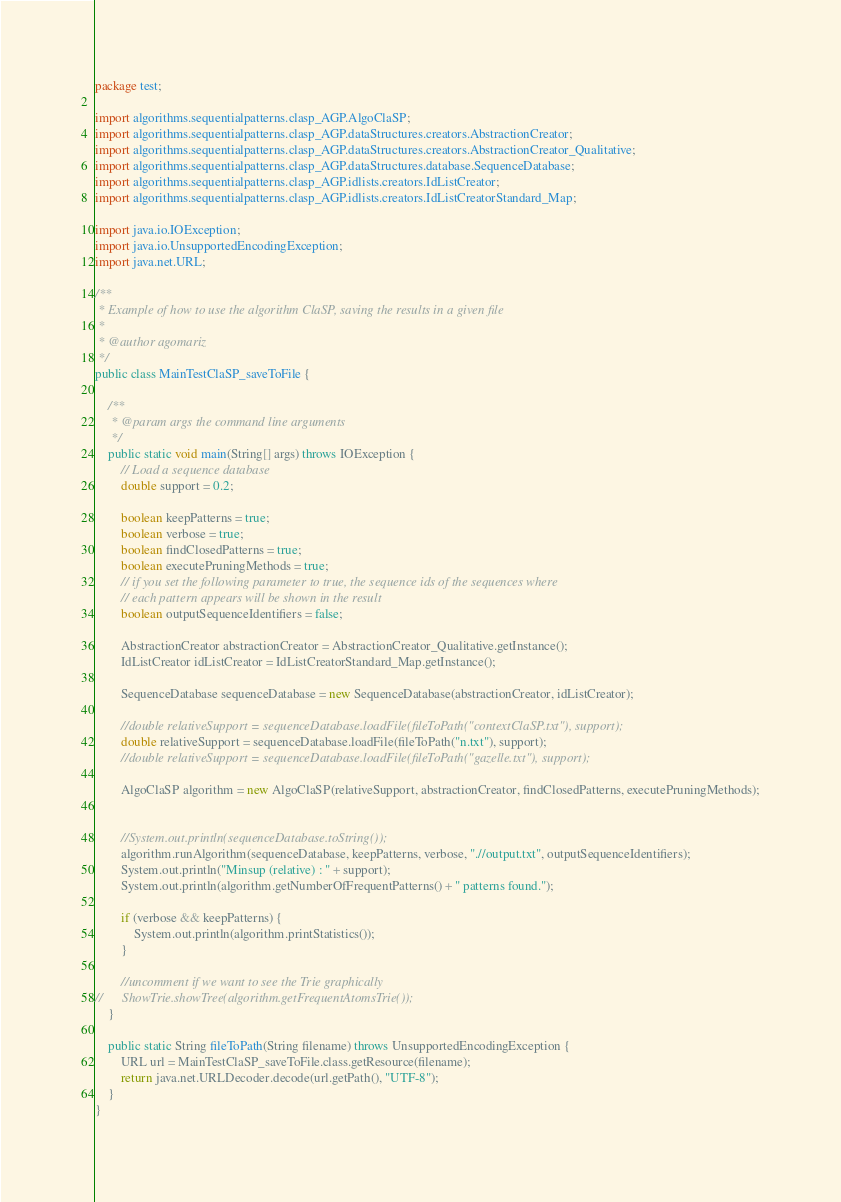<code> <loc_0><loc_0><loc_500><loc_500><_Java_>package test;

import algorithms.sequentialpatterns.clasp_AGP.AlgoClaSP;
import algorithms.sequentialpatterns.clasp_AGP.dataStructures.creators.AbstractionCreator;
import algorithms.sequentialpatterns.clasp_AGP.dataStructures.creators.AbstractionCreator_Qualitative;
import algorithms.sequentialpatterns.clasp_AGP.dataStructures.database.SequenceDatabase;
import algorithms.sequentialpatterns.clasp_AGP.idlists.creators.IdListCreator;
import algorithms.sequentialpatterns.clasp_AGP.idlists.creators.IdListCreatorStandard_Map;

import java.io.IOException;
import java.io.UnsupportedEncodingException;
import java.net.URL;

/**
 * Example of how to use the algorithm ClaSP, saving the results in a given file
 *
 * @author agomariz
 */
public class MainTestClaSP_saveToFile {

    /**
     * @param args the command line arguments
     */
    public static void main(String[] args) throws IOException {
        // Load a sequence database
        double support = 0.2;

        boolean keepPatterns = true;
        boolean verbose = true;
        boolean findClosedPatterns = true;
        boolean executePruningMethods = true;
        // if you set the following parameter to true, the sequence ids of the sequences where
        // each pattern appears will be shown in the result
        boolean outputSequenceIdentifiers = false;

        AbstractionCreator abstractionCreator = AbstractionCreator_Qualitative.getInstance();
        IdListCreator idListCreator = IdListCreatorStandard_Map.getInstance();

        SequenceDatabase sequenceDatabase = new SequenceDatabase(abstractionCreator, idListCreator);

        //double relativeSupport = sequenceDatabase.loadFile(fileToPath("contextClaSP.txt"), support);
        double relativeSupport = sequenceDatabase.loadFile(fileToPath("n.txt"), support);
        //double relativeSupport = sequenceDatabase.loadFile(fileToPath("gazelle.txt"), support);

        AlgoClaSP algorithm = new AlgoClaSP(relativeSupport, abstractionCreator, findClosedPatterns, executePruningMethods);


        //System.out.println(sequenceDatabase.toString());
        algorithm.runAlgorithm(sequenceDatabase, keepPatterns, verbose, ".//output.txt", outputSequenceIdentifiers);
        System.out.println("Minsup (relative) : " + support);
        System.out.println(algorithm.getNumberOfFrequentPatterns() + " patterns found.");

        if (verbose && keepPatterns) {
            System.out.println(algorithm.printStatistics());
        }

        //uncomment if we want to see the Trie graphically
//      ShowTrie.showTree(algorithm.getFrequentAtomsTrie());
    }

    public static String fileToPath(String filename) throws UnsupportedEncodingException {
        URL url = MainTestClaSP_saveToFile.class.getResource(filename);
        return java.net.URLDecoder.decode(url.getPath(), "UTF-8");
    }
}
</code> 